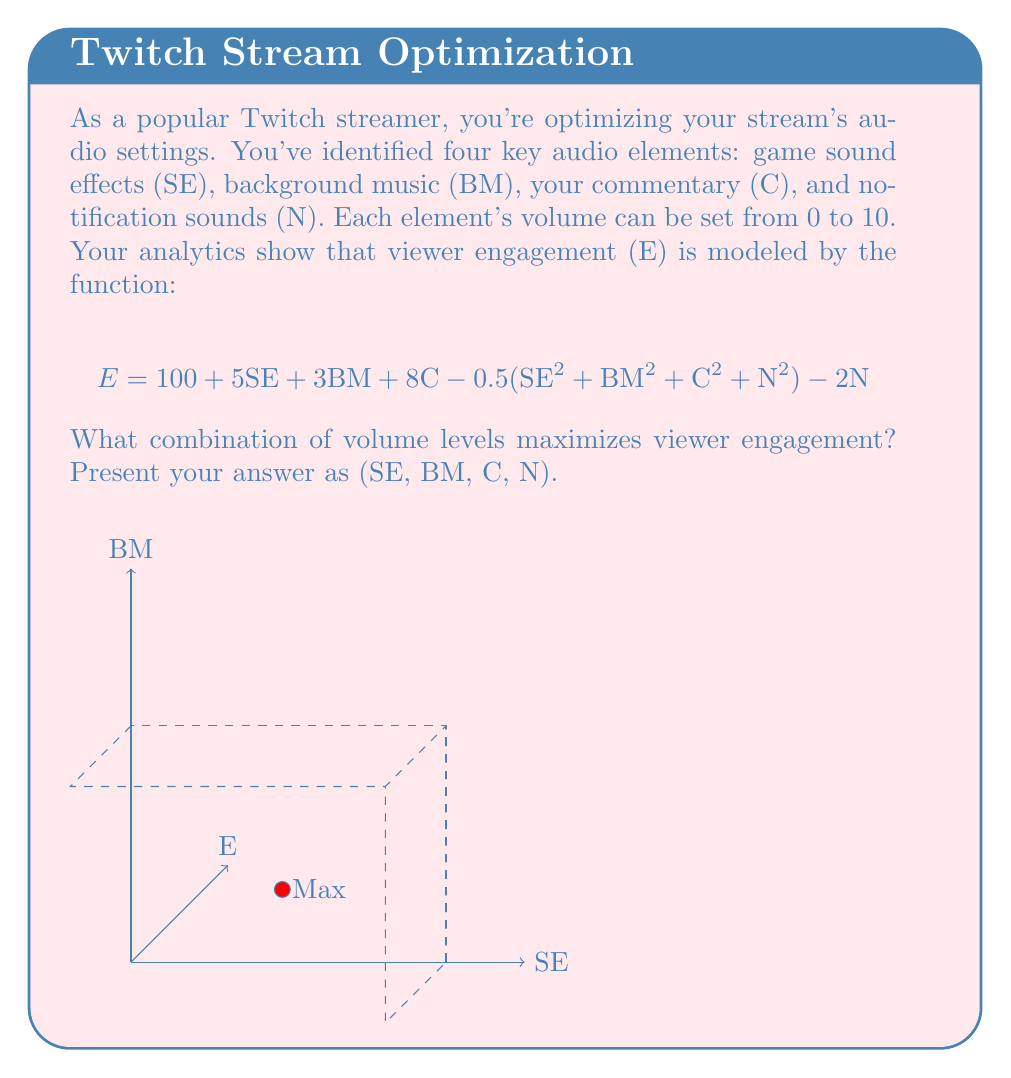Help me with this question. To maximize the viewer engagement, we need to find the critical points of the function E with respect to each variable. We'll do this by taking partial derivatives and setting them to zero:

1) For SE: 
   $$\frac{\partial E}{\partial SE} = 5 - SE = 0$$
   $$SE = 5$$

2) For BM:
   $$\frac{\partial E}{\partial BM} = 3 - BM = 0$$
   $$BM = 3$$

3) For C:
   $$\frac{\partial E}{\partial C} = 8 - C = 0$$
   $$C = 8$$

4) For N:
   $$\frac{\partial E}{\partial N} = -N - 2 = 0$$
   $$N = -2$$

However, since volume levels can't be negative, we need to adjust N to the closest valid value, which is 0.

To confirm this is a maximum, we can check the second derivatives, which are all negative, indicating a concave down function.

The Hessian matrix is:
$$H = \begin{bmatrix} 
-1 & 0 & 0 & 0\\
0 & -1 & 0 & 0\\
0 & 0 & -1 & 0\\
0 & 0 & 0 & -1
\end{bmatrix}$$

Since all eigenvalues of H are negative, this critical point is indeed a maximum.
Answer: (5, 3, 8, 0) 